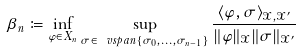<formula> <loc_0><loc_0><loc_500><loc_500>\beta _ { n } \coloneqq \inf _ { \varphi \in X _ { n } } \sup _ { \sigma \in \ v s p a n \{ \sigma _ { 0 } , \dots , \sigma _ { n - 1 } \} } \frac { \langle \varphi , \sigma \rangle _ { \mathcal { X } , \mathcal { X } ^ { \prime } } } { \| \varphi \| _ { \mathcal { X } } \| \sigma \| _ { \mathcal { X } ^ { \prime } } }</formula> 